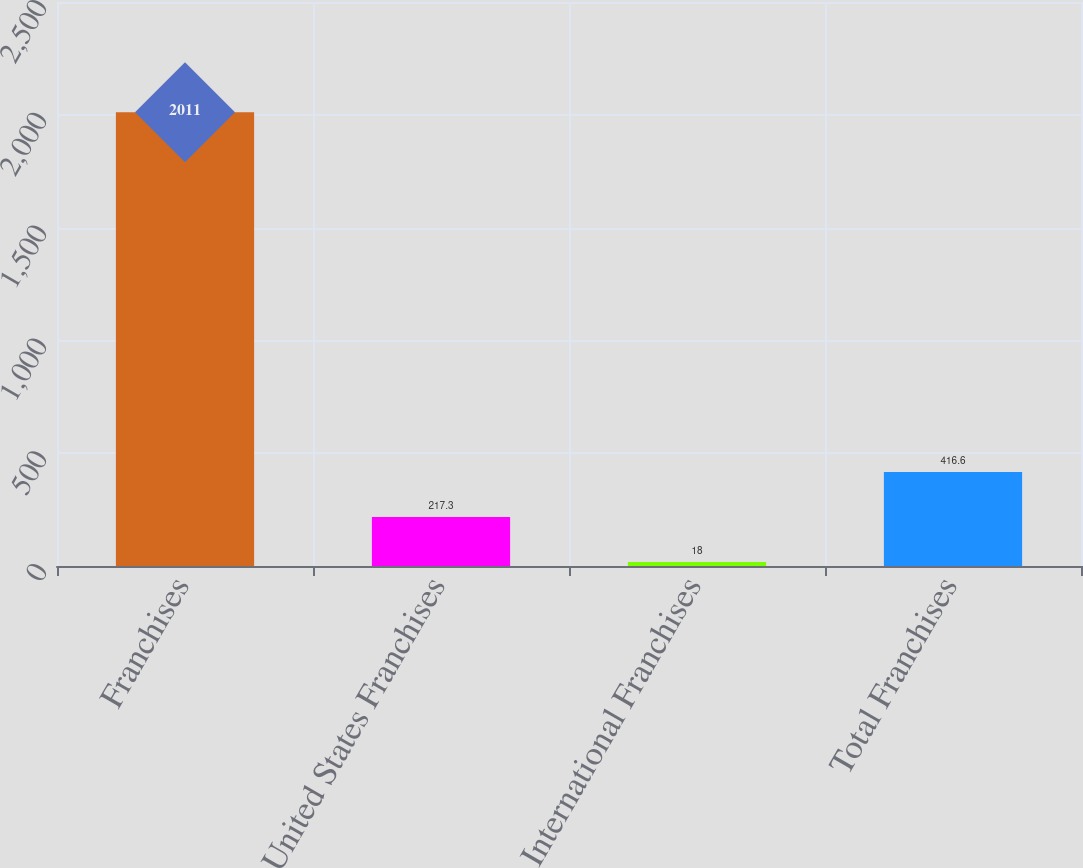<chart> <loc_0><loc_0><loc_500><loc_500><bar_chart><fcel>Franchises<fcel>United States Franchises<fcel>International Franchises<fcel>Total Franchises<nl><fcel>2011<fcel>217.3<fcel>18<fcel>416.6<nl></chart> 